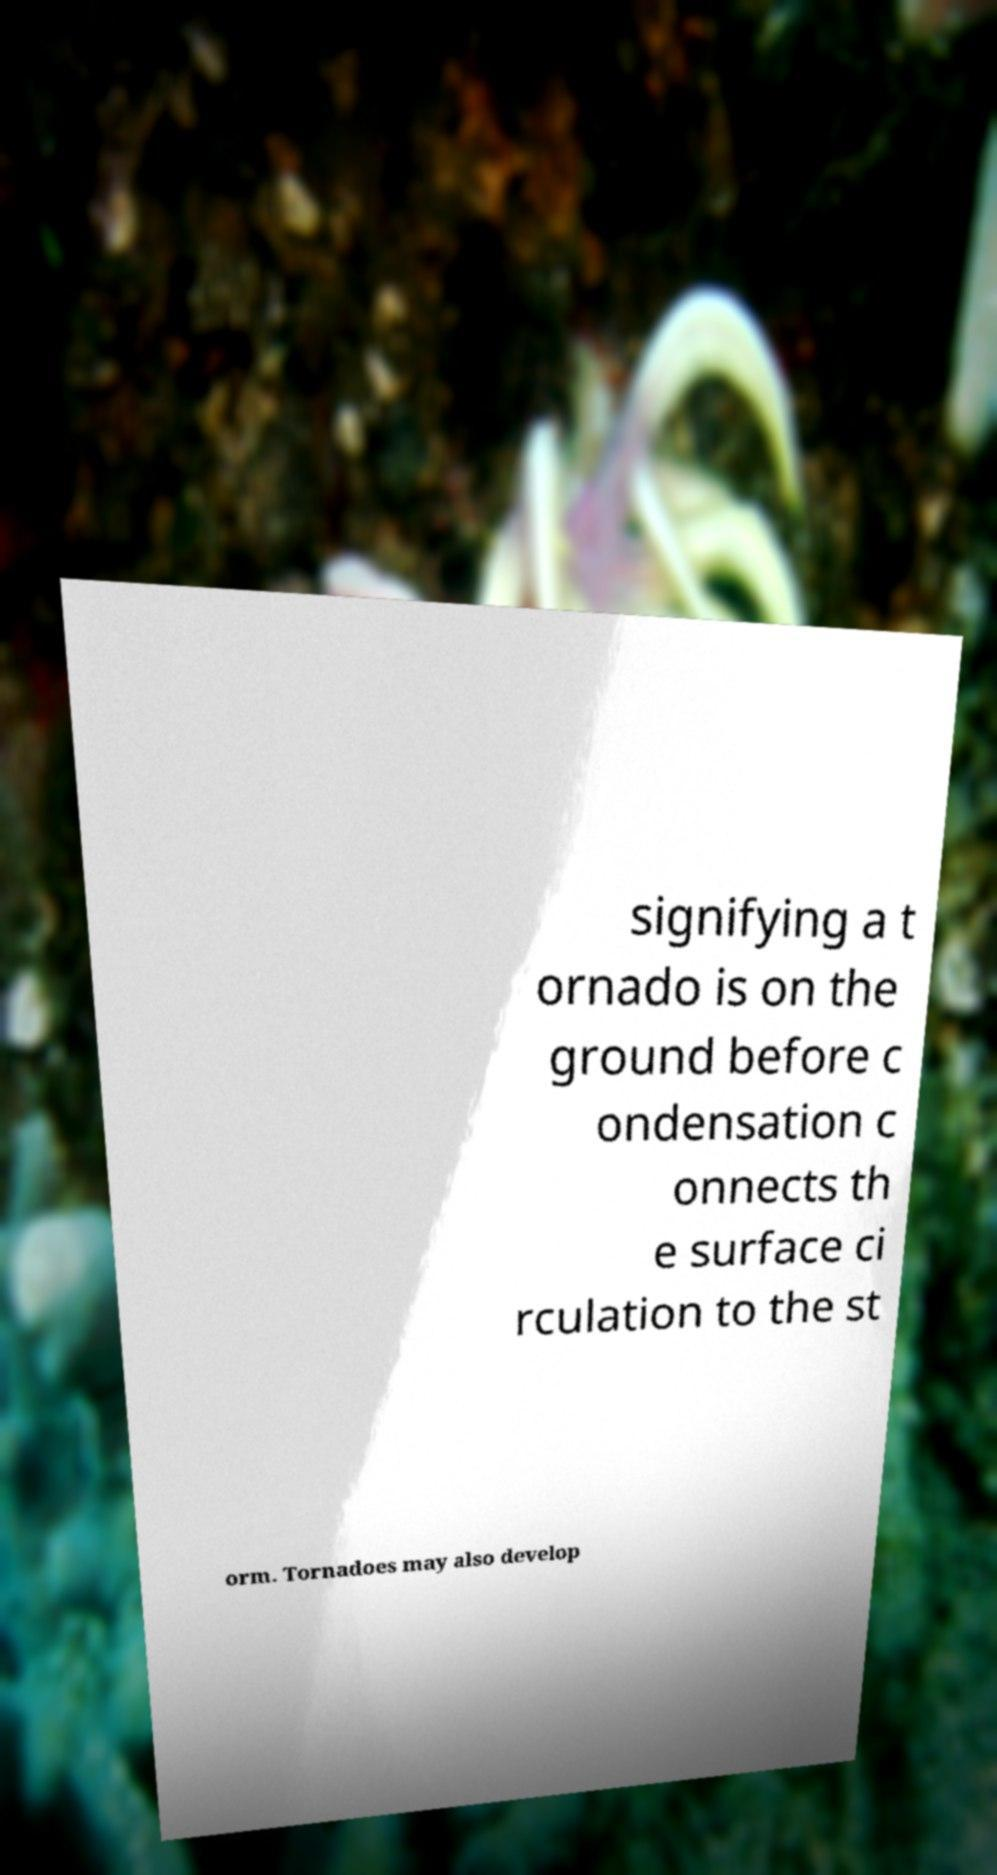Can you accurately transcribe the text from the provided image for me? signifying a t ornado is on the ground before c ondensation c onnects th e surface ci rculation to the st orm. Tornadoes may also develop 